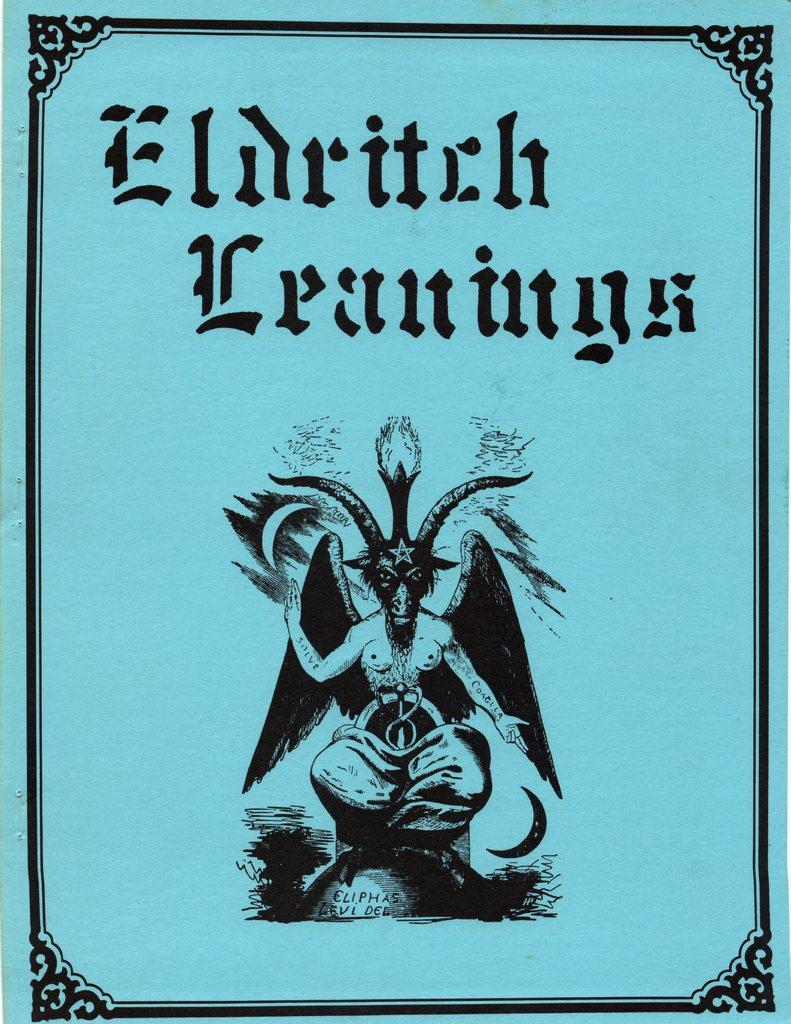<image>
Describe the image concisely. A blue sheet of paper has a demon looking figure with horns with the title Eldritch Leanings. 